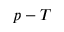Convert formula to latex. <formula><loc_0><loc_0><loc_500><loc_500>p - T</formula> 